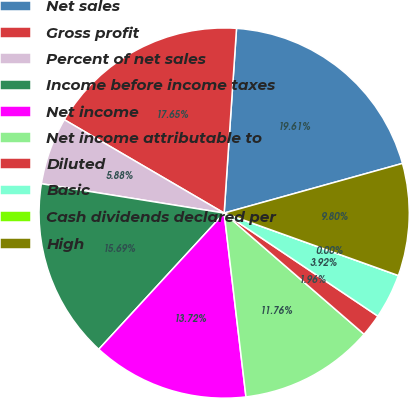Convert chart to OTSL. <chart><loc_0><loc_0><loc_500><loc_500><pie_chart><fcel>Net sales<fcel>Gross profit<fcel>Percent of net sales<fcel>Income before income taxes<fcel>Net income<fcel>Net income attributable to<fcel>Diluted<fcel>Basic<fcel>Cash dividends declared per<fcel>High<nl><fcel>19.61%<fcel>17.65%<fcel>5.88%<fcel>15.69%<fcel>13.72%<fcel>11.76%<fcel>1.96%<fcel>3.92%<fcel>0.0%<fcel>9.8%<nl></chart> 